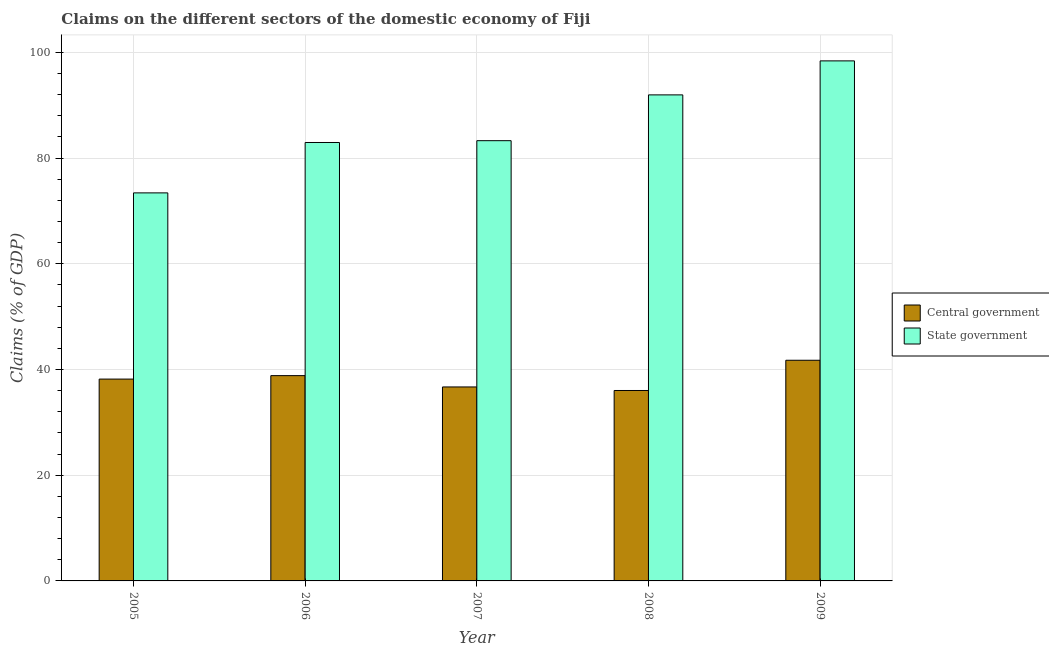How many groups of bars are there?
Your answer should be compact. 5. What is the label of the 4th group of bars from the left?
Ensure brevity in your answer.  2008. In how many cases, is the number of bars for a given year not equal to the number of legend labels?
Keep it short and to the point. 0. What is the claims on state government in 2009?
Give a very brief answer. 98.38. Across all years, what is the maximum claims on central government?
Provide a short and direct response. 41.74. Across all years, what is the minimum claims on central government?
Your response must be concise. 36.02. In which year was the claims on central government maximum?
Your answer should be compact. 2009. In which year was the claims on central government minimum?
Ensure brevity in your answer.  2008. What is the total claims on state government in the graph?
Offer a very short reply. 429.94. What is the difference between the claims on central government in 2005 and that in 2008?
Offer a terse response. 2.16. What is the difference between the claims on state government in 2005 and the claims on central government in 2006?
Your response must be concise. -9.53. What is the average claims on central government per year?
Give a very brief answer. 38.3. In the year 2009, what is the difference between the claims on central government and claims on state government?
Provide a short and direct response. 0. In how many years, is the claims on state government greater than 24 %?
Give a very brief answer. 5. What is the ratio of the claims on state government in 2006 to that in 2008?
Offer a very short reply. 0.9. Is the claims on central government in 2005 less than that in 2006?
Provide a short and direct response. Yes. What is the difference between the highest and the second highest claims on state government?
Offer a terse response. 6.43. What is the difference between the highest and the lowest claims on central government?
Keep it short and to the point. 5.72. In how many years, is the claims on state government greater than the average claims on state government taken over all years?
Offer a very short reply. 2. What does the 2nd bar from the left in 2005 represents?
Your response must be concise. State government. What does the 2nd bar from the right in 2008 represents?
Make the answer very short. Central government. Are all the bars in the graph horizontal?
Give a very brief answer. No. How many years are there in the graph?
Provide a succinct answer. 5. Does the graph contain any zero values?
Give a very brief answer. No. How many legend labels are there?
Offer a very short reply. 2. How are the legend labels stacked?
Provide a succinct answer. Vertical. What is the title of the graph?
Ensure brevity in your answer.  Claims on the different sectors of the domestic economy of Fiji. What is the label or title of the X-axis?
Your answer should be compact. Year. What is the label or title of the Y-axis?
Ensure brevity in your answer.  Claims (% of GDP). What is the Claims (% of GDP) in Central government in 2005?
Provide a short and direct response. 38.18. What is the Claims (% of GDP) of State government in 2005?
Give a very brief answer. 73.4. What is the Claims (% of GDP) of Central government in 2006?
Your answer should be compact. 38.83. What is the Claims (% of GDP) of State government in 2006?
Make the answer very short. 82.94. What is the Claims (% of GDP) in Central government in 2007?
Provide a short and direct response. 36.69. What is the Claims (% of GDP) in State government in 2007?
Offer a very short reply. 83.28. What is the Claims (% of GDP) of Central government in 2008?
Offer a very short reply. 36.02. What is the Claims (% of GDP) in State government in 2008?
Provide a short and direct response. 91.94. What is the Claims (% of GDP) of Central government in 2009?
Offer a very short reply. 41.74. What is the Claims (% of GDP) of State government in 2009?
Give a very brief answer. 98.38. Across all years, what is the maximum Claims (% of GDP) of Central government?
Ensure brevity in your answer.  41.74. Across all years, what is the maximum Claims (% of GDP) in State government?
Provide a short and direct response. 98.38. Across all years, what is the minimum Claims (% of GDP) of Central government?
Make the answer very short. 36.02. Across all years, what is the minimum Claims (% of GDP) of State government?
Provide a short and direct response. 73.4. What is the total Claims (% of GDP) of Central government in the graph?
Make the answer very short. 191.48. What is the total Claims (% of GDP) in State government in the graph?
Provide a succinct answer. 429.94. What is the difference between the Claims (% of GDP) of Central government in 2005 and that in 2006?
Give a very brief answer. -0.65. What is the difference between the Claims (% of GDP) of State government in 2005 and that in 2006?
Provide a succinct answer. -9.53. What is the difference between the Claims (% of GDP) in Central government in 2005 and that in 2007?
Ensure brevity in your answer.  1.49. What is the difference between the Claims (% of GDP) in State government in 2005 and that in 2007?
Your answer should be very brief. -9.87. What is the difference between the Claims (% of GDP) of Central government in 2005 and that in 2008?
Your response must be concise. 2.16. What is the difference between the Claims (% of GDP) of State government in 2005 and that in 2008?
Provide a short and direct response. -18.54. What is the difference between the Claims (% of GDP) of Central government in 2005 and that in 2009?
Ensure brevity in your answer.  -3.56. What is the difference between the Claims (% of GDP) of State government in 2005 and that in 2009?
Offer a terse response. -24.97. What is the difference between the Claims (% of GDP) of Central government in 2006 and that in 2007?
Your answer should be compact. 2.14. What is the difference between the Claims (% of GDP) of State government in 2006 and that in 2007?
Make the answer very short. -0.34. What is the difference between the Claims (% of GDP) in Central government in 2006 and that in 2008?
Keep it short and to the point. 2.81. What is the difference between the Claims (% of GDP) of State government in 2006 and that in 2008?
Keep it short and to the point. -9. What is the difference between the Claims (% of GDP) of Central government in 2006 and that in 2009?
Provide a succinct answer. -2.91. What is the difference between the Claims (% of GDP) in State government in 2006 and that in 2009?
Offer a terse response. -15.44. What is the difference between the Claims (% of GDP) of Central government in 2007 and that in 2008?
Provide a succinct answer. 0.67. What is the difference between the Claims (% of GDP) in State government in 2007 and that in 2008?
Your response must be concise. -8.66. What is the difference between the Claims (% of GDP) in Central government in 2007 and that in 2009?
Provide a succinct answer. -5.05. What is the difference between the Claims (% of GDP) of State government in 2007 and that in 2009?
Offer a very short reply. -15.1. What is the difference between the Claims (% of GDP) of Central government in 2008 and that in 2009?
Keep it short and to the point. -5.72. What is the difference between the Claims (% of GDP) of State government in 2008 and that in 2009?
Your answer should be compact. -6.43. What is the difference between the Claims (% of GDP) of Central government in 2005 and the Claims (% of GDP) of State government in 2006?
Offer a very short reply. -44.76. What is the difference between the Claims (% of GDP) of Central government in 2005 and the Claims (% of GDP) of State government in 2007?
Provide a short and direct response. -45.1. What is the difference between the Claims (% of GDP) of Central government in 2005 and the Claims (% of GDP) of State government in 2008?
Give a very brief answer. -53.76. What is the difference between the Claims (% of GDP) in Central government in 2005 and the Claims (% of GDP) in State government in 2009?
Your response must be concise. -60.2. What is the difference between the Claims (% of GDP) in Central government in 2006 and the Claims (% of GDP) in State government in 2007?
Ensure brevity in your answer.  -44.44. What is the difference between the Claims (% of GDP) of Central government in 2006 and the Claims (% of GDP) of State government in 2008?
Your answer should be very brief. -53.11. What is the difference between the Claims (% of GDP) in Central government in 2006 and the Claims (% of GDP) in State government in 2009?
Provide a succinct answer. -59.54. What is the difference between the Claims (% of GDP) of Central government in 2007 and the Claims (% of GDP) of State government in 2008?
Your response must be concise. -55.25. What is the difference between the Claims (% of GDP) of Central government in 2007 and the Claims (% of GDP) of State government in 2009?
Make the answer very short. -61.68. What is the difference between the Claims (% of GDP) in Central government in 2008 and the Claims (% of GDP) in State government in 2009?
Your response must be concise. -62.35. What is the average Claims (% of GDP) in Central government per year?
Provide a succinct answer. 38.3. What is the average Claims (% of GDP) of State government per year?
Give a very brief answer. 85.99. In the year 2005, what is the difference between the Claims (% of GDP) in Central government and Claims (% of GDP) in State government?
Your answer should be very brief. -35.23. In the year 2006, what is the difference between the Claims (% of GDP) of Central government and Claims (% of GDP) of State government?
Your answer should be very brief. -44.1. In the year 2007, what is the difference between the Claims (% of GDP) in Central government and Claims (% of GDP) in State government?
Your answer should be compact. -46.59. In the year 2008, what is the difference between the Claims (% of GDP) in Central government and Claims (% of GDP) in State government?
Provide a succinct answer. -55.92. In the year 2009, what is the difference between the Claims (% of GDP) of Central government and Claims (% of GDP) of State government?
Your response must be concise. -56.63. What is the ratio of the Claims (% of GDP) of Central government in 2005 to that in 2006?
Provide a succinct answer. 0.98. What is the ratio of the Claims (% of GDP) in State government in 2005 to that in 2006?
Give a very brief answer. 0.89. What is the ratio of the Claims (% of GDP) of Central government in 2005 to that in 2007?
Ensure brevity in your answer.  1.04. What is the ratio of the Claims (% of GDP) of State government in 2005 to that in 2007?
Keep it short and to the point. 0.88. What is the ratio of the Claims (% of GDP) of Central government in 2005 to that in 2008?
Your answer should be compact. 1.06. What is the ratio of the Claims (% of GDP) in State government in 2005 to that in 2008?
Your answer should be very brief. 0.8. What is the ratio of the Claims (% of GDP) of Central government in 2005 to that in 2009?
Offer a very short reply. 0.91. What is the ratio of the Claims (% of GDP) in State government in 2005 to that in 2009?
Make the answer very short. 0.75. What is the ratio of the Claims (% of GDP) of Central government in 2006 to that in 2007?
Your answer should be compact. 1.06. What is the ratio of the Claims (% of GDP) of Central government in 2006 to that in 2008?
Offer a terse response. 1.08. What is the ratio of the Claims (% of GDP) in State government in 2006 to that in 2008?
Give a very brief answer. 0.9. What is the ratio of the Claims (% of GDP) in Central government in 2006 to that in 2009?
Offer a terse response. 0.93. What is the ratio of the Claims (% of GDP) of State government in 2006 to that in 2009?
Ensure brevity in your answer.  0.84. What is the ratio of the Claims (% of GDP) of Central government in 2007 to that in 2008?
Your answer should be very brief. 1.02. What is the ratio of the Claims (% of GDP) of State government in 2007 to that in 2008?
Your response must be concise. 0.91. What is the ratio of the Claims (% of GDP) of Central government in 2007 to that in 2009?
Your answer should be very brief. 0.88. What is the ratio of the Claims (% of GDP) of State government in 2007 to that in 2009?
Ensure brevity in your answer.  0.85. What is the ratio of the Claims (% of GDP) of Central government in 2008 to that in 2009?
Provide a succinct answer. 0.86. What is the ratio of the Claims (% of GDP) in State government in 2008 to that in 2009?
Give a very brief answer. 0.93. What is the difference between the highest and the second highest Claims (% of GDP) of Central government?
Provide a succinct answer. 2.91. What is the difference between the highest and the second highest Claims (% of GDP) of State government?
Provide a short and direct response. 6.43. What is the difference between the highest and the lowest Claims (% of GDP) in Central government?
Provide a short and direct response. 5.72. What is the difference between the highest and the lowest Claims (% of GDP) in State government?
Ensure brevity in your answer.  24.97. 